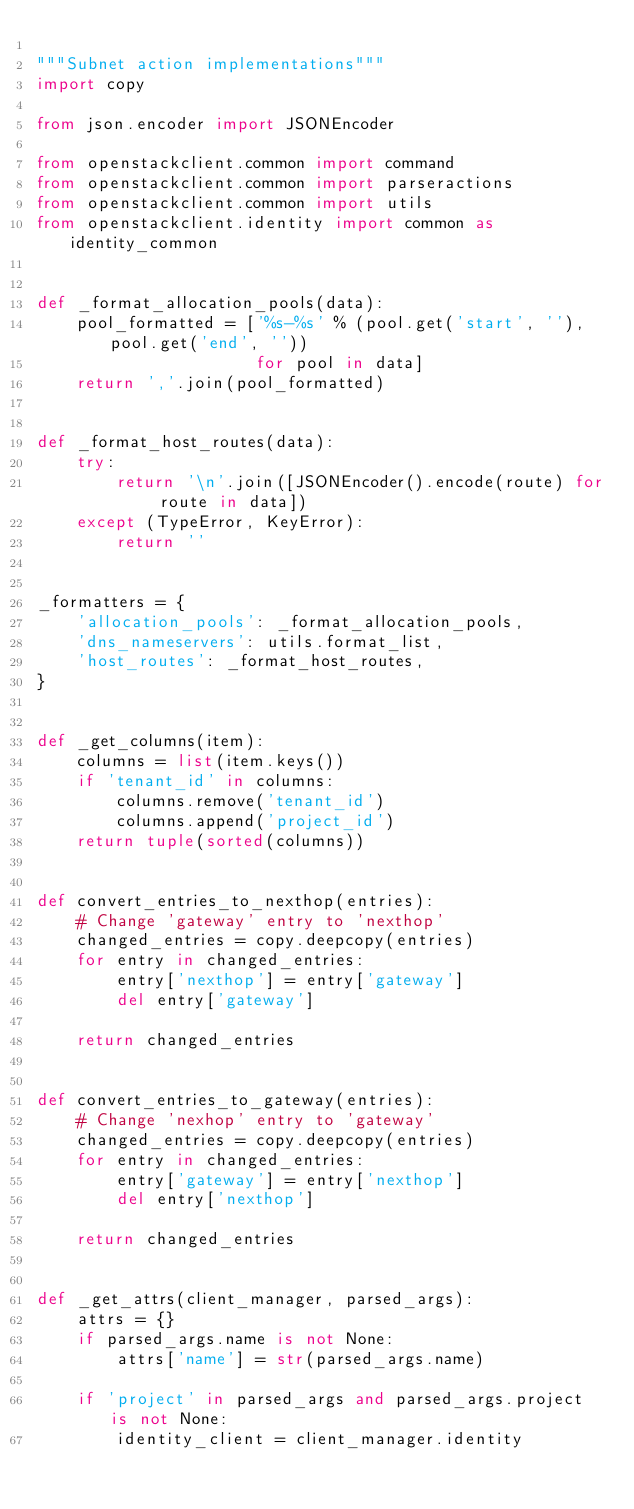Convert code to text. <code><loc_0><loc_0><loc_500><loc_500><_Python_>
"""Subnet action implementations"""
import copy

from json.encoder import JSONEncoder

from openstackclient.common import command
from openstackclient.common import parseractions
from openstackclient.common import utils
from openstackclient.identity import common as identity_common


def _format_allocation_pools(data):
    pool_formatted = ['%s-%s' % (pool.get('start', ''), pool.get('end', ''))
                      for pool in data]
    return ','.join(pool_formatted)


def _format_host_routes(data):
    try:
        return '\n'.join([JSONEncoder().encode(route) for route in data])
    except (TypeError, KeyError):
        return ''


_formatters = {
    'allocation_pools': _format_allocation_pools,
    'dns_nameservers': utils.format_list,
    'host_routes': _format_host_routes,
}


def _get_columns(item):
    columns = list(item.keys())
    if 'tenant_id' in columns:
        columns.remove('tenant_id')
        columns.append('project_id')
    return tuple(sorted(columns))


def convert_entries_to_nexthop(entries):
    # Change 'gateway' entry to 'nexthop'
    changed_entries = copy.deepcopy(entries)
    for entry in changed_entries:
        entry['nexthop'] = entry['gateway']
        del entry['gateway']

    return changed_entries


def convert_entries_to_gateway(entries):
    # Change 'nexhop' entry to 'gateway'
    changed_entries = copy.deepcopy(entries)
    for entry in changed_entries:
        entry['gateway'] = entry['nexthop']
        del entry['nexthop']

    return changed_entries


def _get_attrs(client_manager, parsed_args):
    attrs = {}
    if parsed_args.name is not None:
        attrs['name'] = str(parsed_args.name)

    if 'project' in parsed_args and parsed_args.project is not None:
        identity_client = client_manager.identity</code> 